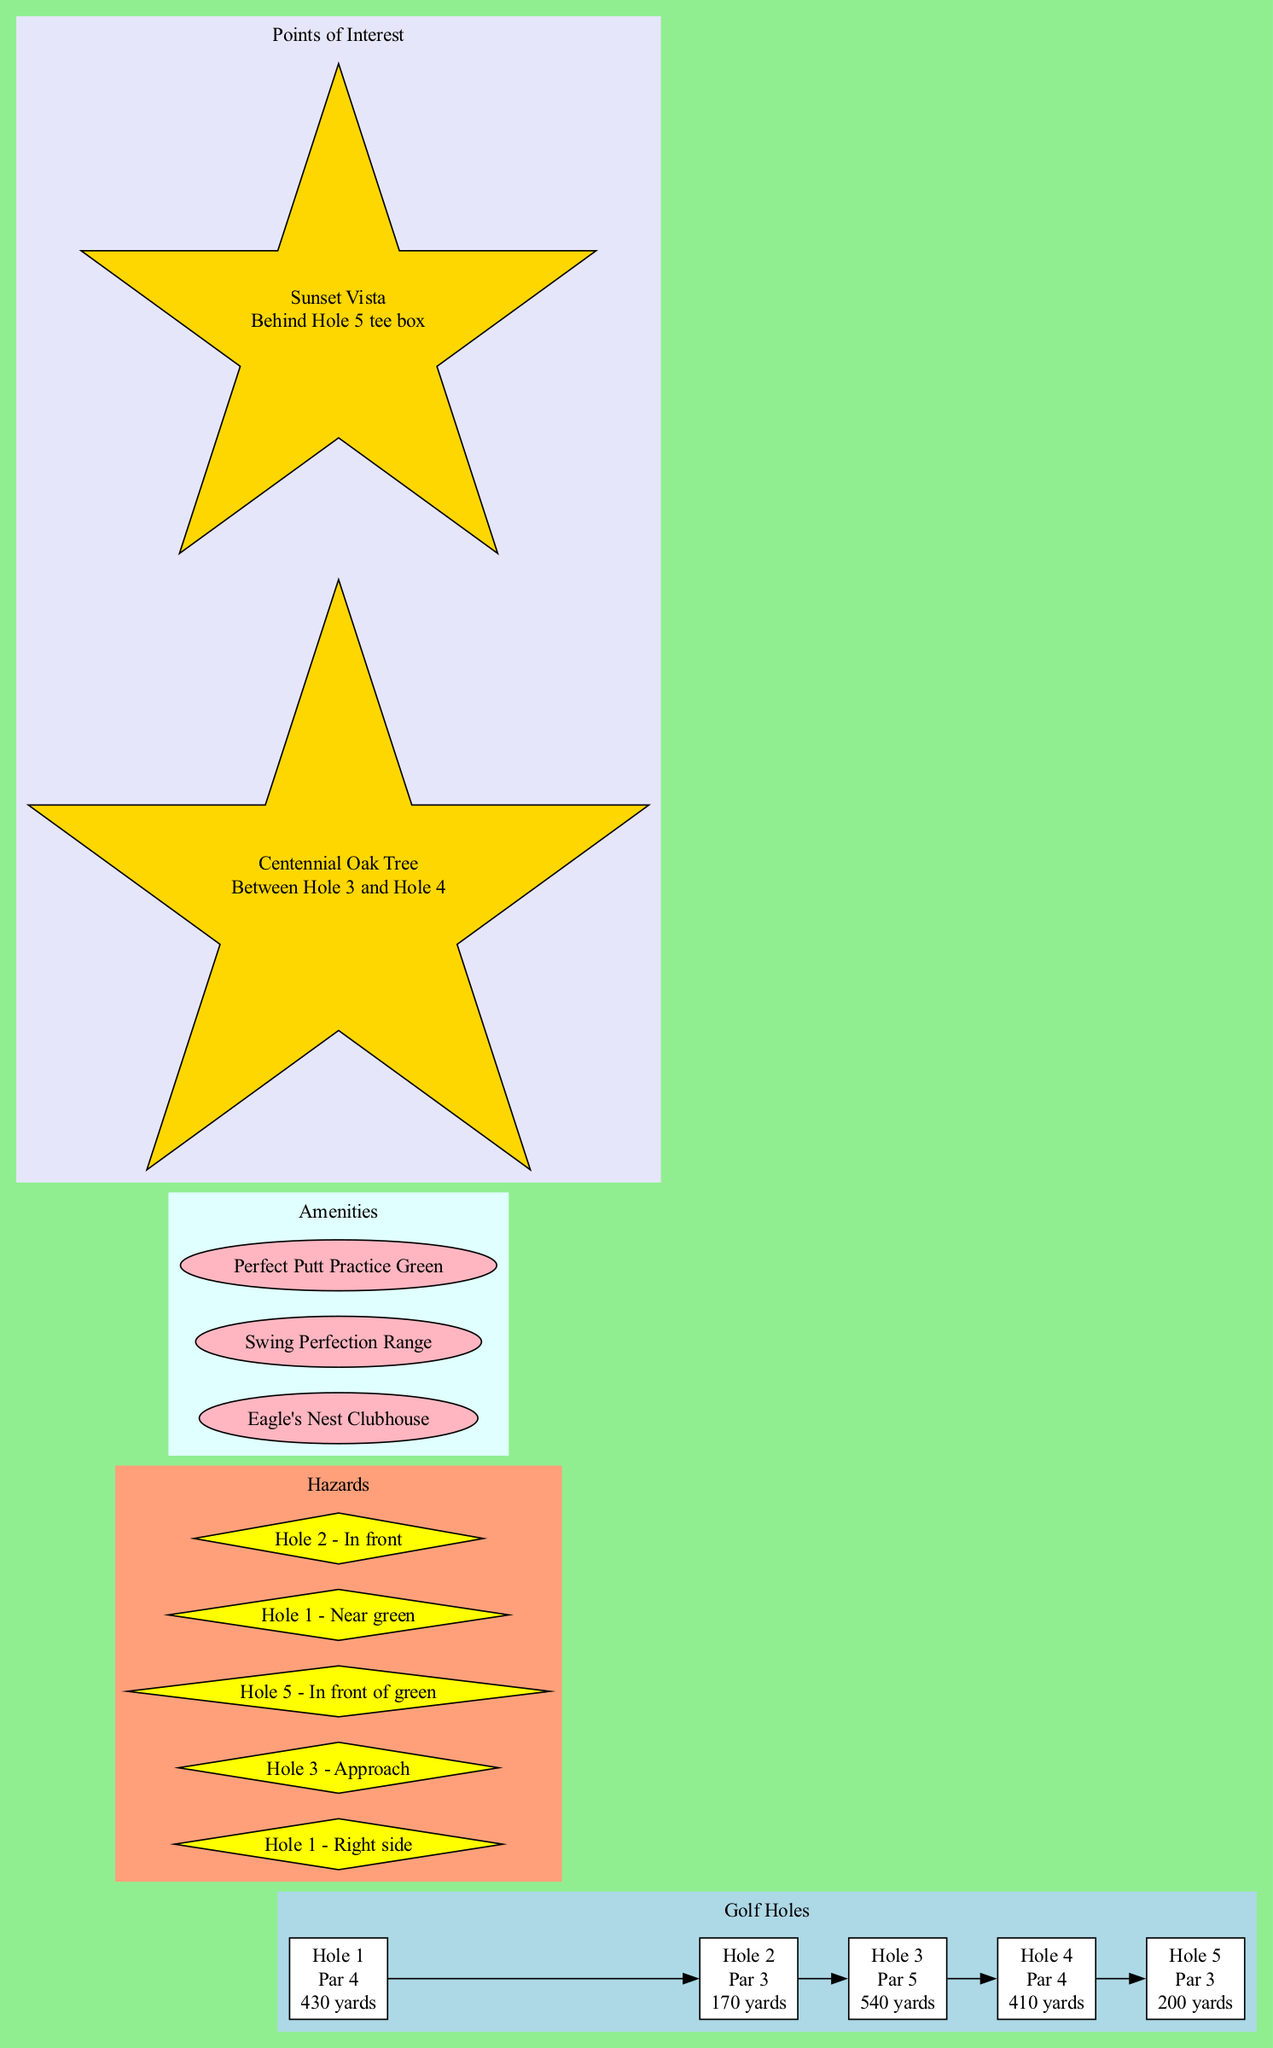What is the hole number for Par 3 with yardage 200? To find the answer, we look at the hole type and yardage; the diagram indicates that Hole 5 is a Par 3 with a yardage of 200.
Answer: 5 How many sand traps are there on the golf course? By examining the hazards section, we see there are three instances mentioned as sand traps: one for Hole 1, one for Hole 3, and one for Hole 5, which totals to three.
Answer: 3 Which hole features a water hazard in front? We look at the holes that mention water hazards and find that Hole 2 specifically states that it has a water hazard in front of it.
Answer: Hole 2 What features are available at the Eagle's Nest Clubhouse? The amenities section describes the Eagle's Nest Clubhouse and lists its features: pro shop, restaurant, and lounge area, which provides a clear answer to the inquiry.
Answer: Pro shop, restaurant, lounge area Which hole has a dogleg left? From the description of the holes, it's clear that Hole 1 is characterized by having a dogleg left, hence answering the question directly.
Answer: Hole 1 How many holes are there on the golf course? Counting the provided hole entries in the diagram reveals five distinct holes, as listed in the holes section.
Answer: 5 What type of hazard is located near the green on Hole 1? Referring to the hazards section, it states that Hole 1 features a sand trap on the right side and a water hazard near the green, thus the answer involves both hazard types.
Answer: Water hazard Where is the Perfect Putt Practice Green located? The amenities section lists the name of the putting green, but does not specify its location. However, since it is presented in the diagram format, it can be inferred it is part of the course layout, available for practice.
Answer: N/A Which was the last hole before Hole 3? The flow from the diagram indicates that Hole 2 comes directly before Hole 3, showing the sequential order of the layout.
Answer: Hole 2 